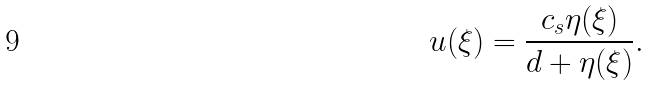Convert formula to latex. <formula><loc_0><loc_0><loc_500><loc_500>u ( \xi ) = \frac { c _ { s } \eta ( \xi ) } { d + \eta ( \xi ) } .</formula> 